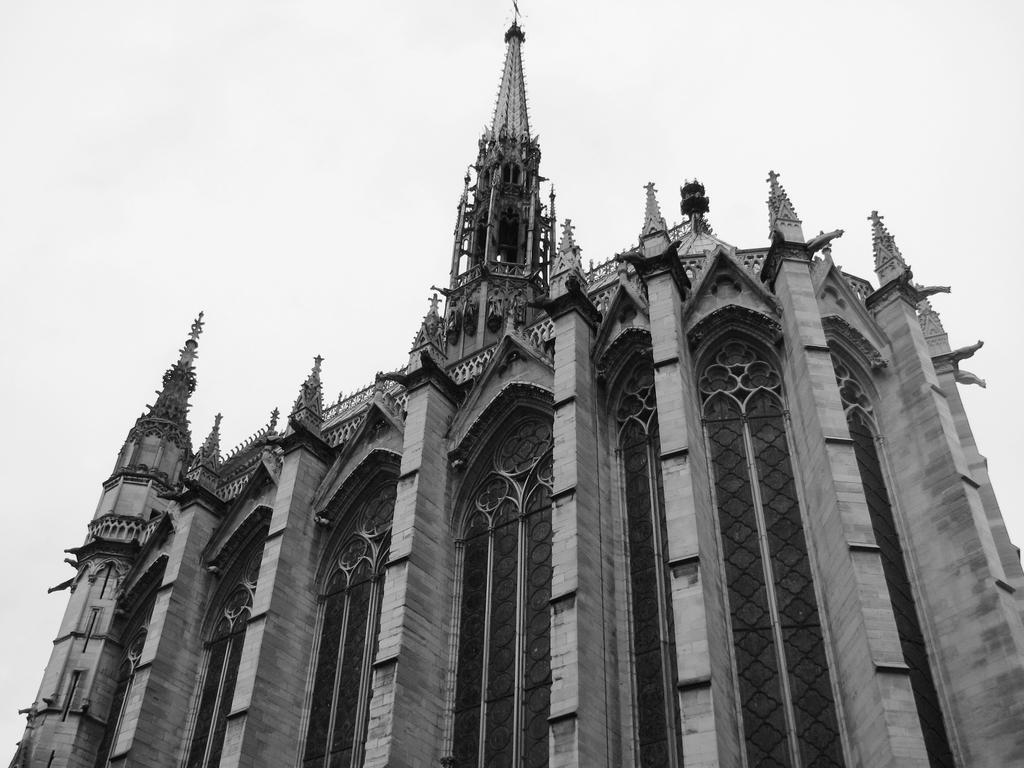Describe this image in one or two sentences. In this image in the center there is one building, and at the top of the image there is sky and in the center there are some railings. 